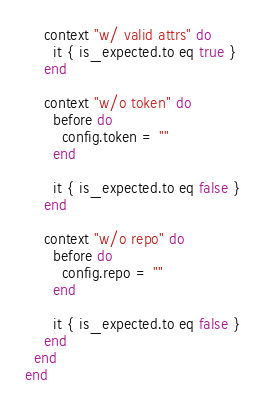Convert code to text. <code><loc_0><loc_0><loc_500><loc_500><_Ruby_>
    context "w/ valid attrs" do
      it { is_expected.to eq true }
    end

    context "w/o token" do
      before do
        config.token = ""
      end

      it { is_expected.to eq false }
    end

    context "w/o repo" do
      before do
        config.repo = ""
      end

      it { is_expected.to eq false }
    end
  end
end

</code> 